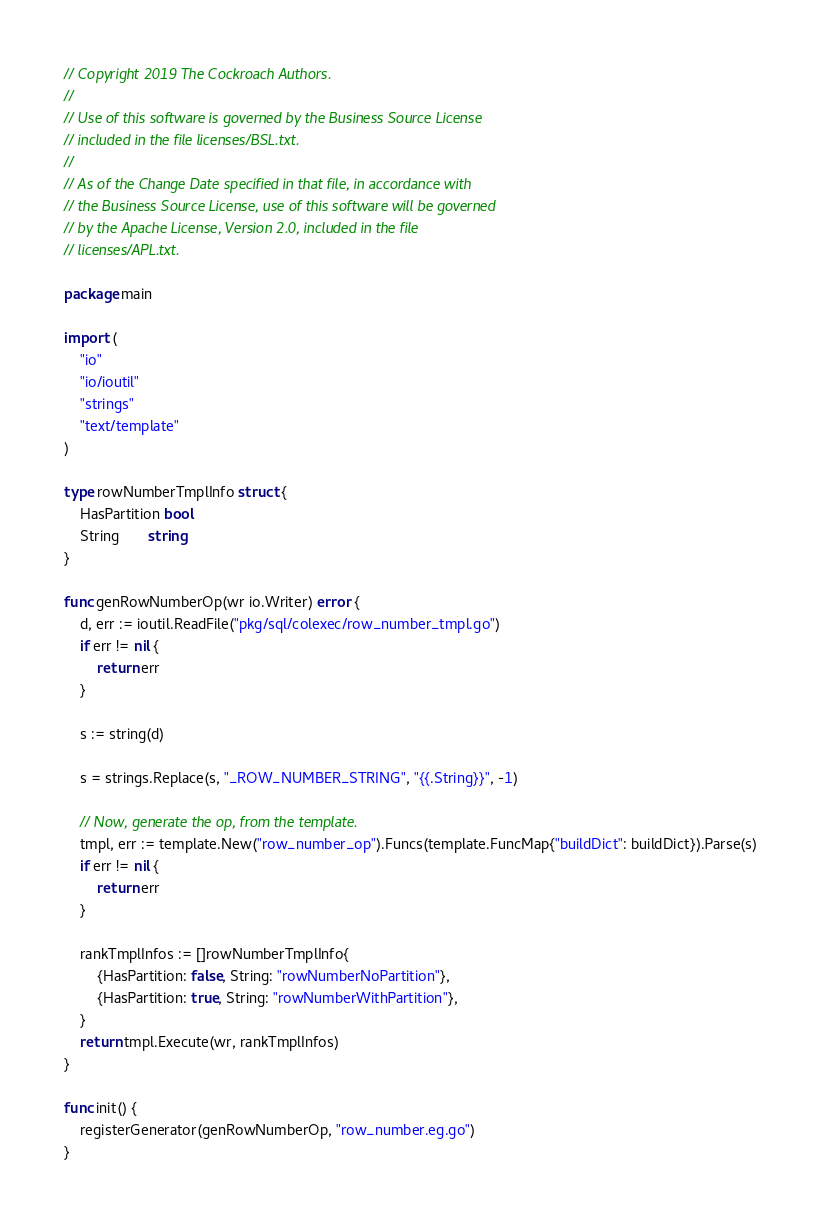<code> <loc_0><loc_0><loc_500><loc_500><_Go_>// Copyright 2019 The Cockroach Authors.
//
// Use of this software is governed by the Business Source License
// included in the file licenses/BSL.txt.
//
// As of the Change Date specified in that file, in accordance with
// the Business Source License, use of this software will be governed
// by the Apache License, Version 2.0, included in the file
// licenses/APL.txt.

package main

import (
	"io"
	"io/ioutil"
	"strings"
	"text/template"
)

type rowNumberTmplInfo struct {
	HasPartition bool
	String       string
}

func genRowNumberOp(wr io.Writer) error {
	d, err := ioutil.ReadFile("pkg/sql/colexec/row_number_tmpl.go")
	if err != nil {
		return err
	}

	s := string(d)

	s = strings.Replace(s, "_ROW_NUMBER_STRING", "{{.String}}", -1)

	// Now, generate the op, from the template.
	tmpl, err := template.New("row_number_op").Funcs(template.FuncMap{"buildDict": buildDict}).Parse(s)
	if err != nil {
		return err
	}

	rankTmplInfos := []rowNumberTmplInfo{
		{HasPartition: false, String: "rowNumberNoPartition"},
		{HasPartition: true, String: "rowNumberWithPartition"},
	}
	return tmpl.Execute(wr, rankTmplInfos)
}

func init() {
	registerGenerator(genRowNumberOp, "row_number.eg.go")
}
</code> 